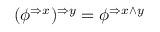<formula> <loc_0><loc_0><loc_500><loc_500>( \phi ^ { \Rightarrow x } ) ^ { \Rightarrow y } = \phi ^ { \Rightarrow x \wedge y }</formula> 